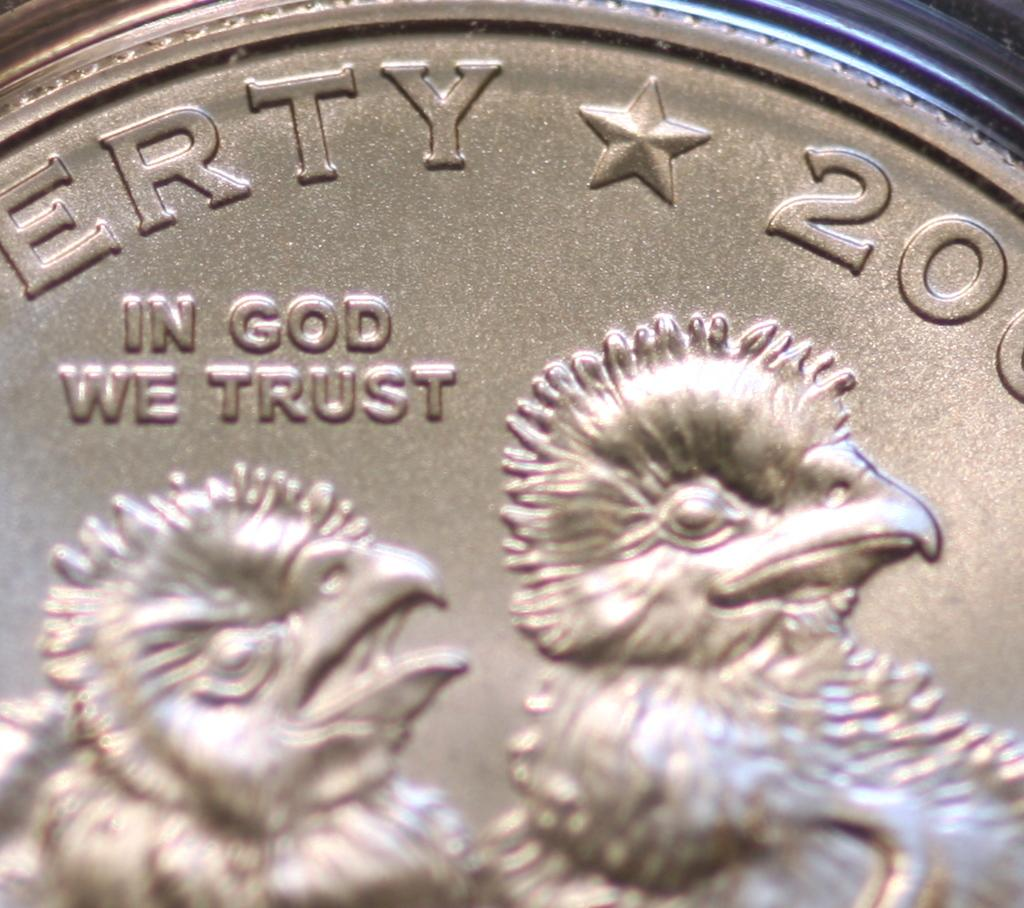<image>
Present a compact description of the photo's key features. a close up of a coin with two chicks reading In God We Trust 